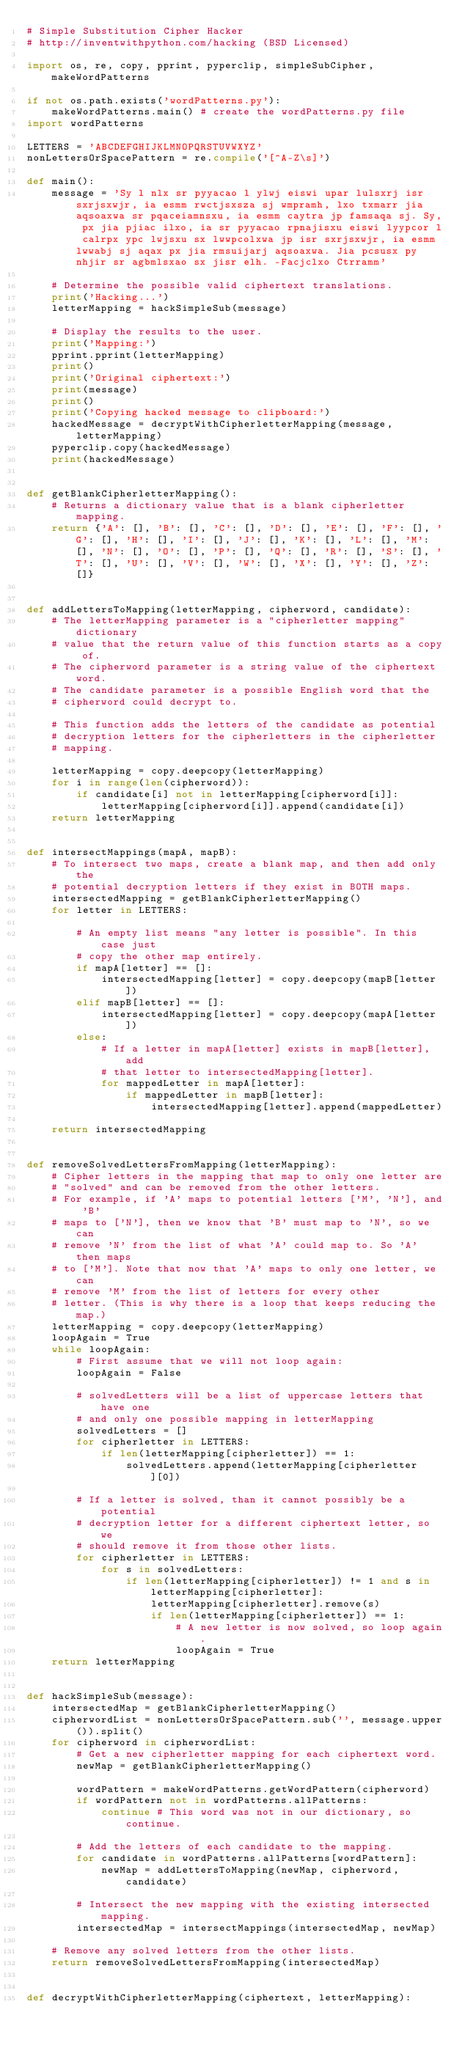<code> <loc_0><loc_0><loc_500><loc_500><_Python_># Simple Substitution Cipher Hacker
# http://inventwithpython.com/hacking (BSD Licensed)

import os, re, copy, pprint, pyperclip, simpleSubCipher, makeWordPatterns

if not os.path.exists('wordPatterns.py'):
    makeWordPatterns.main() # create the wordPatterns.py file
import wordPatterns

LETTERS = 'ABCDEFGHIJKLMNOPQRSTUVWXYZ'
nonLettersOrSpacePattern = re.compile('[^A-Z\s]')

def main():
    message = 'Sy l nlx sr pyyacao l ylwj eiswi upar lulsxrj isr sxrjsxwjr, ia esmm rwctjsxsza sj wmpramh, lxo txmarr jia aqsoaxwa sr pqaceiamnsxu, ia esmm caytra jp famsaqa sj. Sy, px jia pjiac ilxo, ia sr pyyacao rpnajisxu eiswi lyypcor l calrpx ypc lwjsxu sx lwwpcolxwa jp isr sxrjsxwjr, ia esmm lwwabj sj aqax px jia rmsuijarj aqsoaxwa. Jia pcsusx py nhjir sr agbmlsxao sx jisr elh. -Facjclxo Ctrramm'

    # Determine the possible valid ciphertext translations.
    print('Hacking...')
    letterMapping = hackSimpleSub(message)

    # Display the results to the user.
    print('Mapping:')
    pprint.pprint(letterMapping)
    print()
    print('Original ciphertext:')
    print(message)
    print()
    print('Copying hacked message to clipboard:')
    hackedMessage = decryptWithCipherletterMapping(message, letterMapping)
    pyperclip.copy(hackedMessage)
    print(hackedMessage)


def getBlankCipherletterMapping():
    # Returns a dictionary value that is a blank cipherletter mapping.
    return {'A': [], 'B': [], 'C': [], 'D': [], 'E': [], 'F': [], 'G': [], 'H': [], 'I': [], 'J': [], 'K': [], 'L': [], 'M': [], 'N': [], 'O': [], 'P': [], 'Q': [], 'R': [], 'S': [], 'T': [], 'U': [], 'V': [], 'W': [], 'X': [], 'Y': [], 'Z': []}


def addLettersToMapping(letterMapping, cipherword, candidate):
    # The letterMapping parameter is a "cipherletter mapping" dictionary
    # value that the return value of this function starts as a copy of.
    # The cipherword parameter is a string value of the ciphertext word.
    # The candidate parameter is a possible English word that the
    # cipherword could decrypt to.

    # This function adds the letters of the candidate as potential
    # decryption letters for the cipherletters in the cipherletter
    # mapping.

    letterMapping = copy.deepcopy(letterMapping)
    for i in range(len(cipherword)):
        if candidate[i] not in letterMapping[cipherword[i]]:
            letterMapping[cipherword[i]].append(candidate[i])
    return letterMapping


def intersectMappings(mapA, mapB):
    # To intersect two maps, create a blank map, and then add only the
    # potential decryption letters if they exist in BOTH maps.
    intersectedMapping = getBlankCipherletterMapping()
    for letter in LETTERS:

        # An empty list means "any letter is possible". In this case just
        # copy the other map entirely.
        if mapA[letter] == []:
            intersectedMapping[letter] = copy.deepcopy(mapB[letter])
        elif mapB[letter] == []:
            intersectedMapping[letter] = copy.deepcopy(mapA[letter])
        else:
            # If a letter in mapA[letter] exists in mapB[letter], add
            # that letter to intersectedMapping[letter].
            for mappedLetter in mapA[letter]:
                if mappedLetter in mapB[letter]:
                    intersectedMapping[letter].append(mappedLetter)

    return intersectedMapping


def removeSolvedLettersFromMapping(letterMapping):
    # Cipher letters in the mapping that map to only one letter are
    # "solved" and can be removed from the other letters.
    # For example, if 'A' maps to potential letters ['M', 'N'], and 'B'
    # maps to ['N'], then we know that 'B' must map to 'N', so we can
    # remove 'N' from the list of what 'A' could map to. So 'A' then maps
    # to ['M']. Note that now that 'A' maps to only one letter, we can
    # remove 'M' from the list of letters for every other
    # letter. (This is why there is a loop that keeps reducing the map.)
    letterMapping = copy.deepcopy(letterMapping)
    loopAgain = True
    while loopAgain:
        # First assume that we will not loop again:
        loopAgain = False

        # solvedLetters will be a list of uppercase letters that have one
        # and only one possible mapping in letterMapping
        solvedLetters = []
        for cipherletter in LETTERS:
            if len(letterMapping[cipherletter]) == 1:
                solvedLetters.append(letterMapping[cipherletter][0])

        # If a letter is solved, than it cannot possibly be a potential
        # decryption letter for a different ciphertext letter, so we
        # should remove it from those other lists.
        for cipherletter in LETTERS:
            for s in solvedLetters:
                if len(letterMapping[cipherletter]) != 1 and s in letterMapping[cipherletter]:
                    letterMapping[cipherletter].remove(s)
                    if len(letterMapping[cipherletter]) == 1:
                        # A new letter is now solved, so loop again.
                        loopAgain = True
    return letterMapping


def hackSimpleSub(message):
    intersectedMap = getBlankCipherletterMapping()
    cipherwordList = nonLettersOrSpacePattern.sub('', message.upper()).split()
    for cipherword in cipherwordList:
        # Get a new cipherletter mapping for each ciphertext word.
        newMap = getBlankCipherletterMapping()

        wordPattern = makeWordPatterns.getWordPattern(cipherword)
        if wordPattern not in wordPatterns.allPatterns:
            continue # This word was not in our dictionary, so continue.

        # Add the letters of each candidate to the mapping.
        for candidate in wordPatterns.allPatterns[wordPattern]:
            newMap = addLettersToMapping(newMap, cipherword, candidate)

        # Intersect the new mapping with the existing intersected mapping.
        intersectedMap = intersectMappings(intersectedMap, newMap)

    # Remove any solved letters from the other lists.
    return removeSolvedLettersFromMapping(intersectedMap)


def decryptWithCipherletterMapping(ciphertext, letterMapping):</code> 